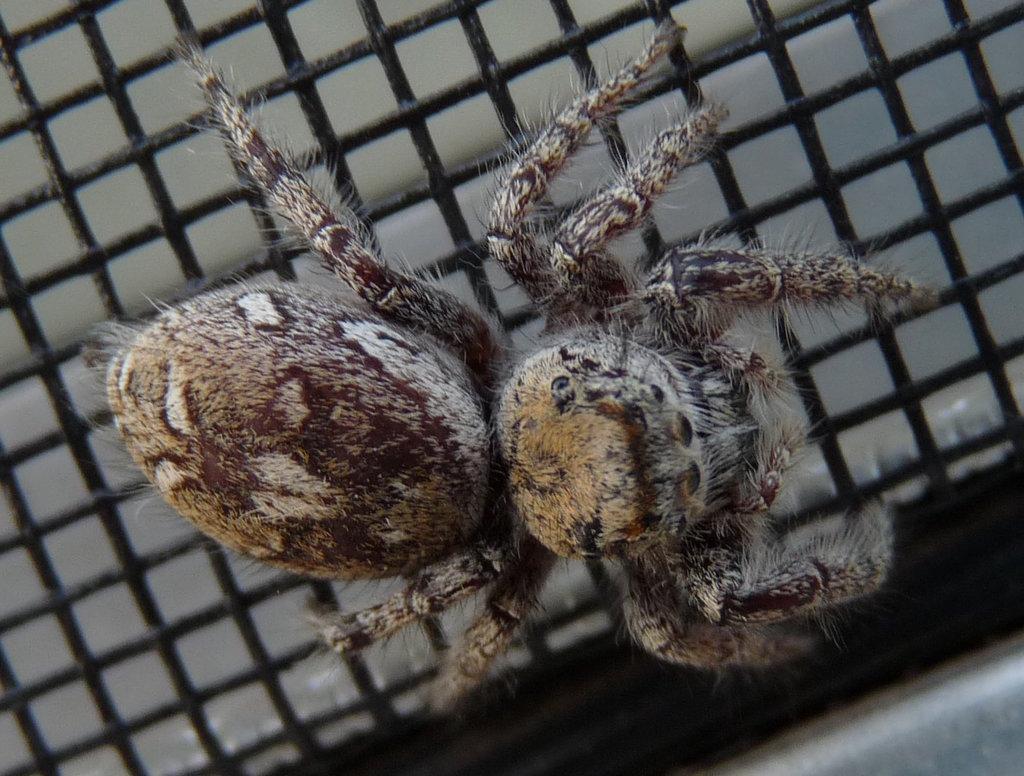How would you summarize this image in a sentence or two? In this picture there is a spider on a black color grill. 